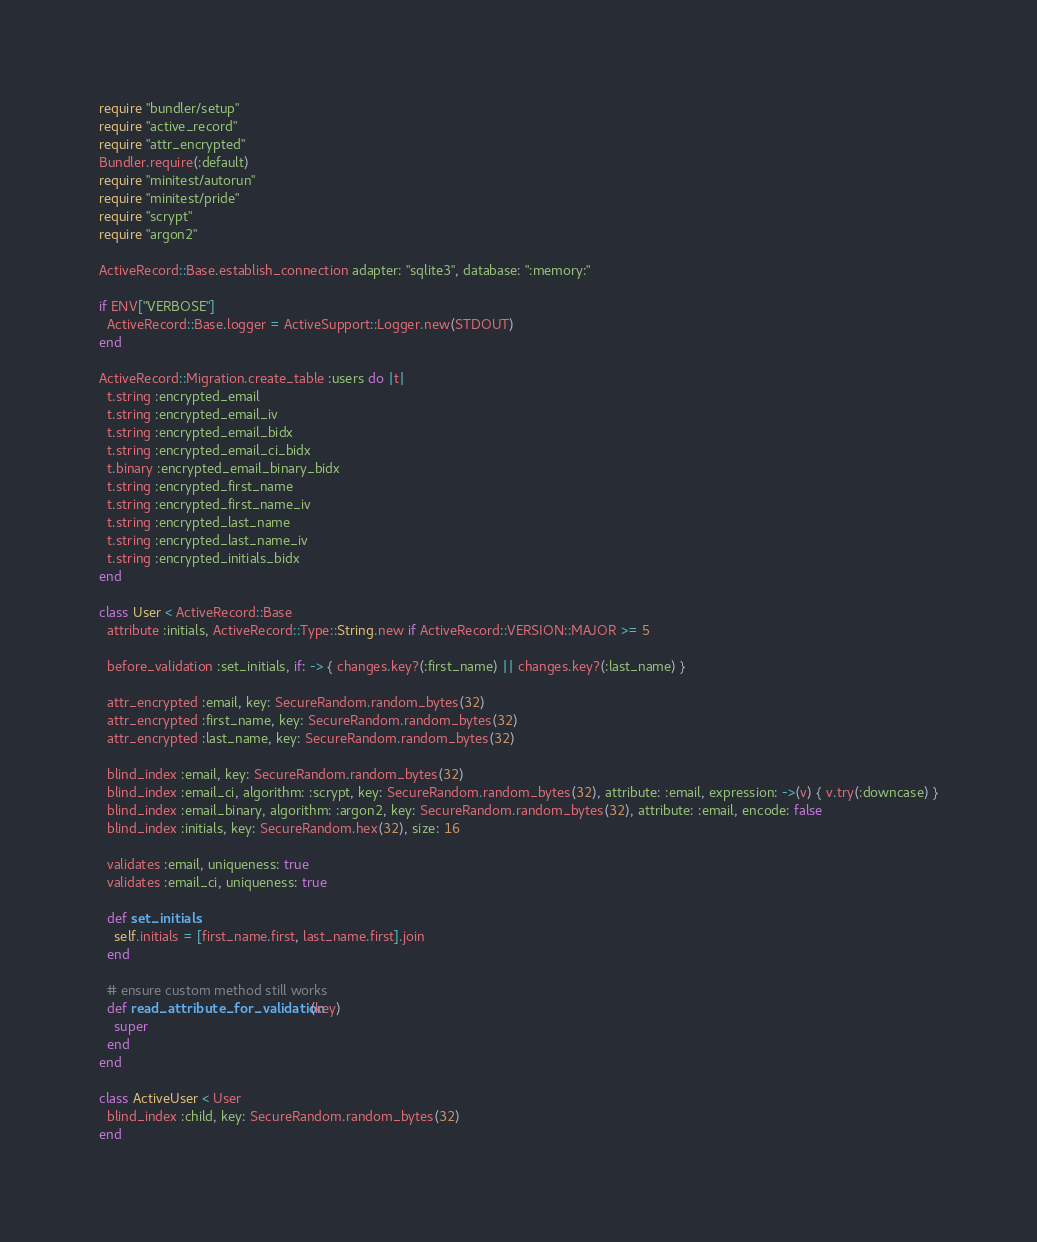Convert code to text. <code><loc_0><loc_0><loc_500><loc_500><_Ruby_>require "bundler/setup"
require "active_record"
require "attr_encrypted"
Bundler.require(:default)
require "minitest/autorun"
require "minitest/pride"
require "scrypt"
require "argon2"

ActiveRecord::Base.establish_connection adapter: "sqlite3", database: ":memory:"

if ENV["VERBOSE"]
  ActiveRecord::Base.logger = ActiveSupport::Logger.new(STDOUT)
end

ActiveRecord::Migration.create_table :users do |t|
  t.string :encrypted_email
  t.string :encrypted_email_iv
  t.string :encrypted_email_bidx
  t.string :encrypted_email_ci_bidx
  t.binary :encrypted_email_binary_bidx
  t.string :encrypted_first_name
  t.string :encrypted_first_name_iv
  t.string :encrypted_last_name
  t.string :encrypted_last_name_iv
  t.string :encrypted_initials_bidx
end

class User < ActiveRecord::Base
  attribute :initials, ActiveRecord::Type::String.new if ActiveRecord::VERSION::MAJOR >= 5

  before_validation :set_initials, if: -> { changes.key?(:first_name) || changes.key?(:last_name) }

  attr_encrypted :email, key: SecureRandom.random_bytes(32)
  attr_encrypted :first_name, key: SecureRandom.random_bytes(32)
  attr_encrypted :last_name, key: SecureRandom.random_bytes(32)

  blind_index :email, key: SecureRandom.random_bytes(32)
  blind_index :email_ci, algorithm: :scrypt, key: SecureRandom.random_bytes(32), attribute: :email, expression: ->(v) { v.try(:downcase) }
  blind_index :email_binary, algorithm: :argon2, key: SecureRandom.random_bytes(32), attribute: :email, encode: false
  blind_index :initials, key: SecureRandom.hex(32), size: 16

  validates :email, uniqueness: true
  validates :email_ci, uniqueness: true

  def set_initials
    self.initials = [first_name.first, last_name.first].join
  end

  # ensure custom method still works
  def read_attribute_for_validation(key)
    super
  end
end

class ActiveUser < User
  blind_index :child, key: SecureRandom.random_bytes(32)
end
</code> 